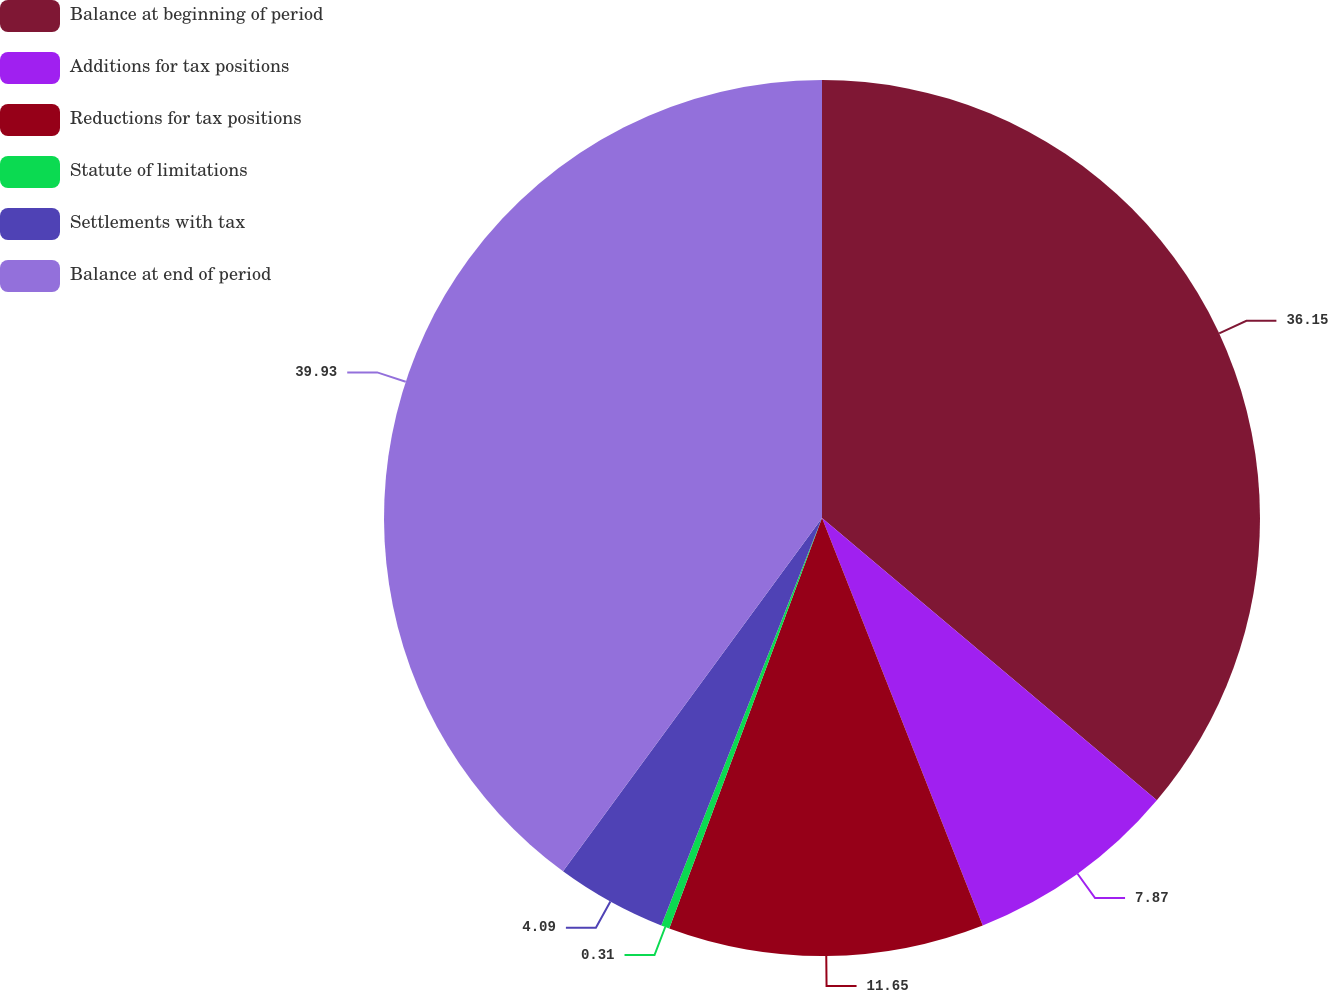Convert chart to OTSL. <chart><loc_0><loc_0><loc_500><loc_500><pie_chart><fcel>Balance at beginning of period<fcel>Additions for tax positions<fcel>Reductions for tax positions<fcel>Statute of limitations<fcel>Settlements with tax<fcel>Balance at end of period<nl><fcel>36.15%<fcel>7.87%<fcel>11.65%<fcel>0.31%<fcel>4.09%<fcel>39.93%<nl></chart> 